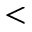Convert formula to latex. <formula><loc_0><loc_0><loc_500><loc_500><</formula> 